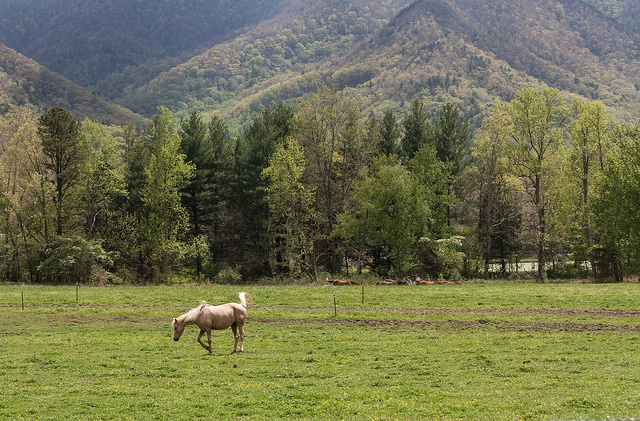Describe the objects in this image and their specific colors. I can see horse in gray, maroon, ivory, and tan tones, cow in gray, maroon, and brown tones, cow in gray, maroon, salmon, and brown tones, cow in gray and black tones, and cow in gray, salmon, tan, maroon, and brown tones in this image. 